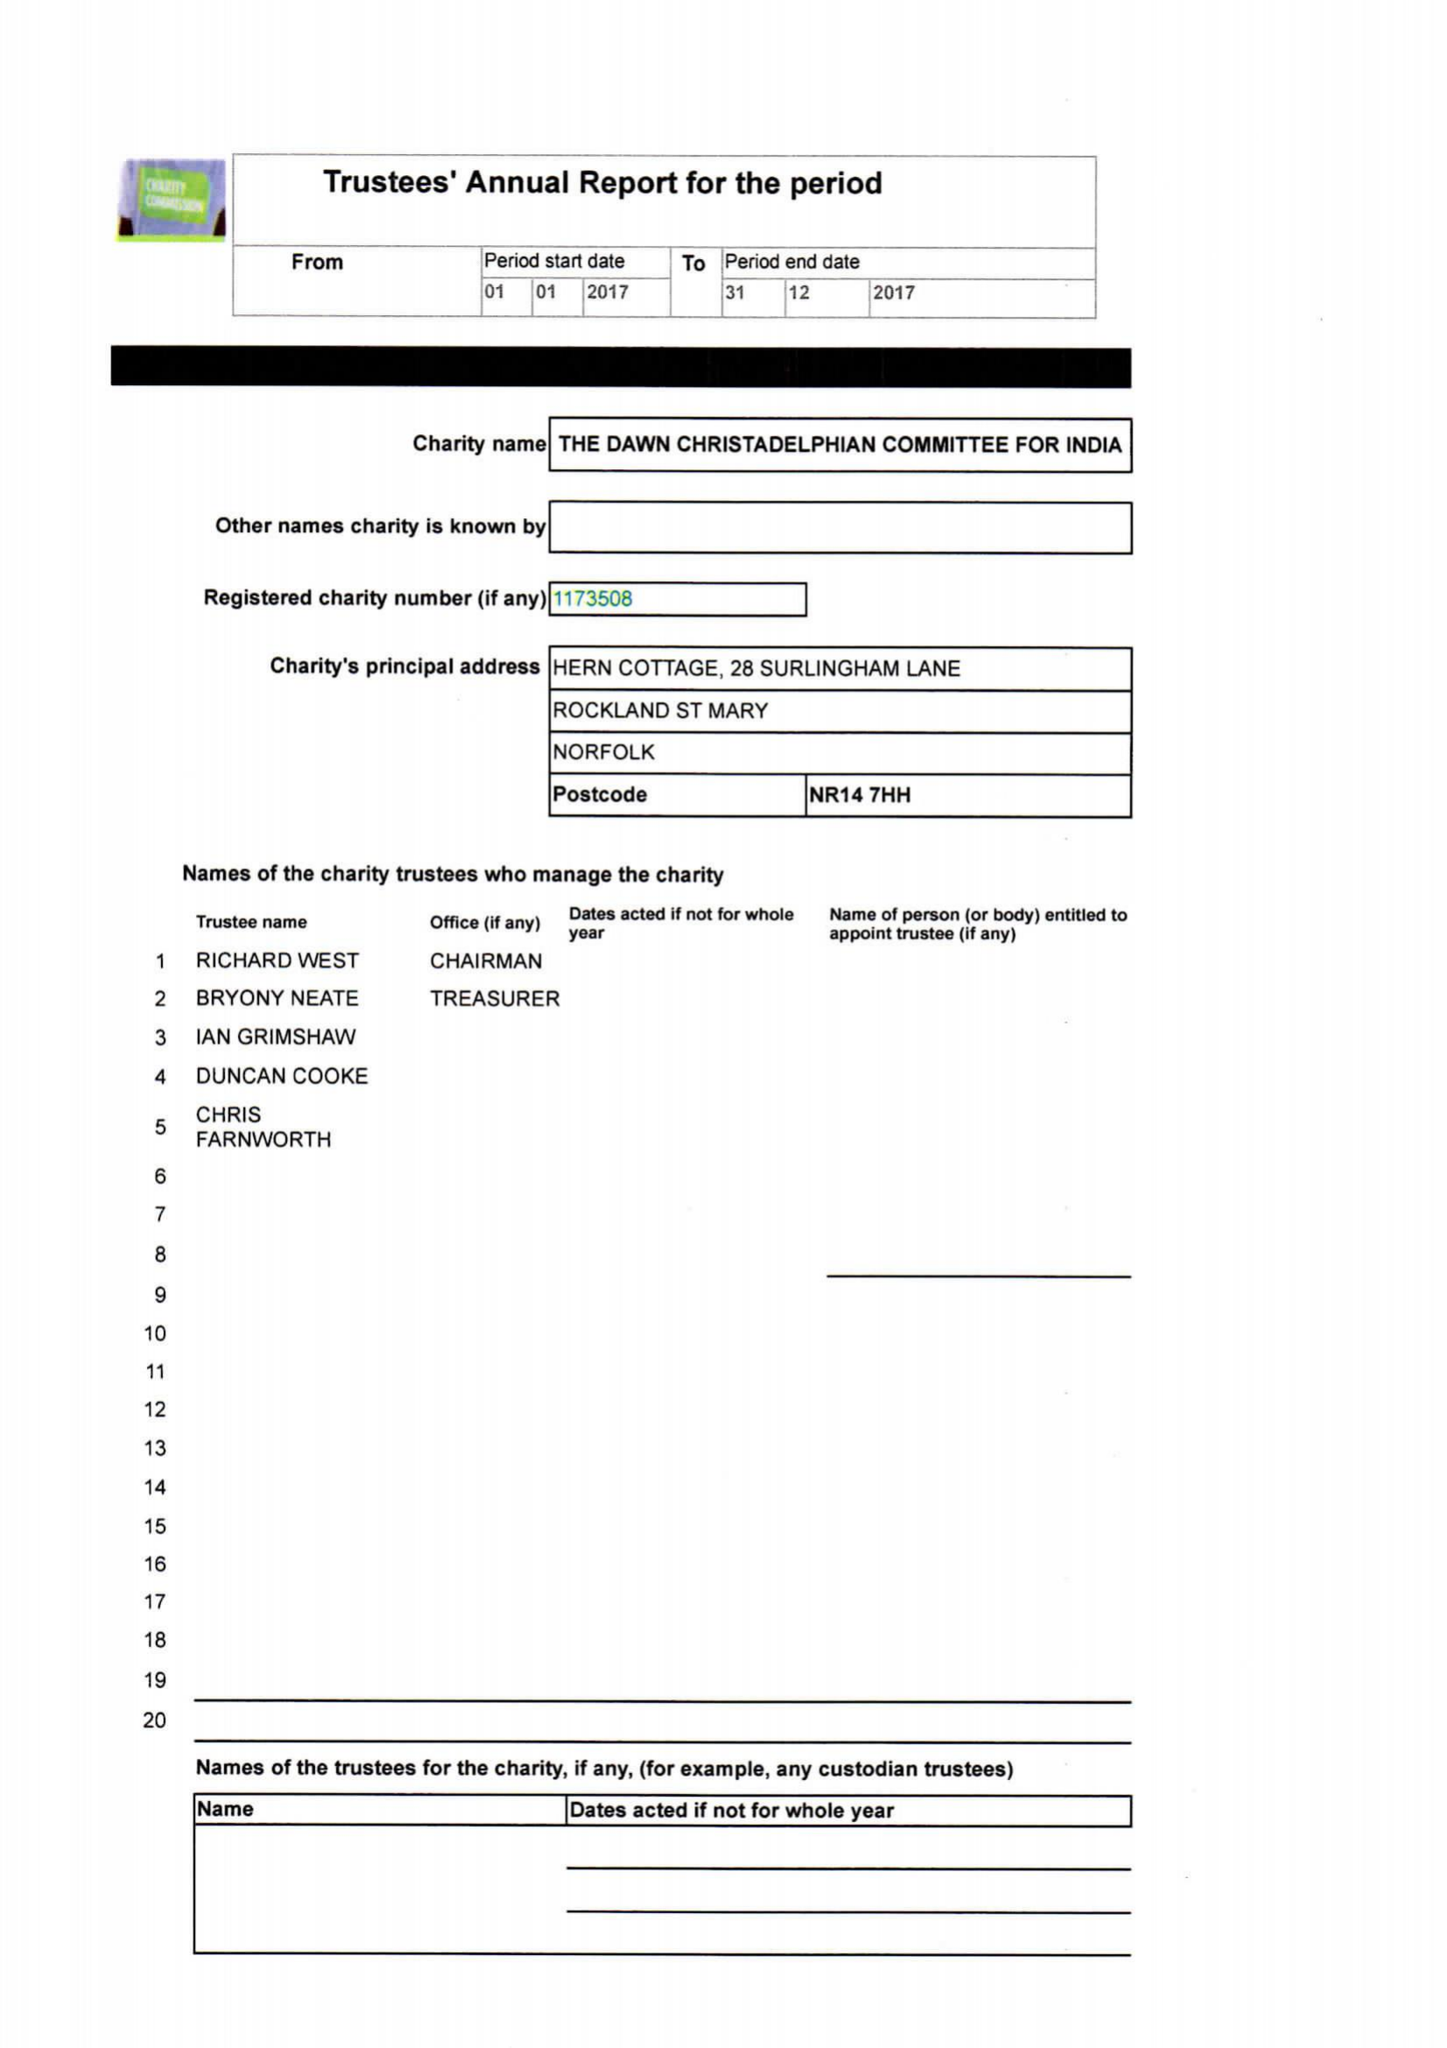What is the value for the report_date?
Answer the question using a single word or phrase. 2017-12-31 